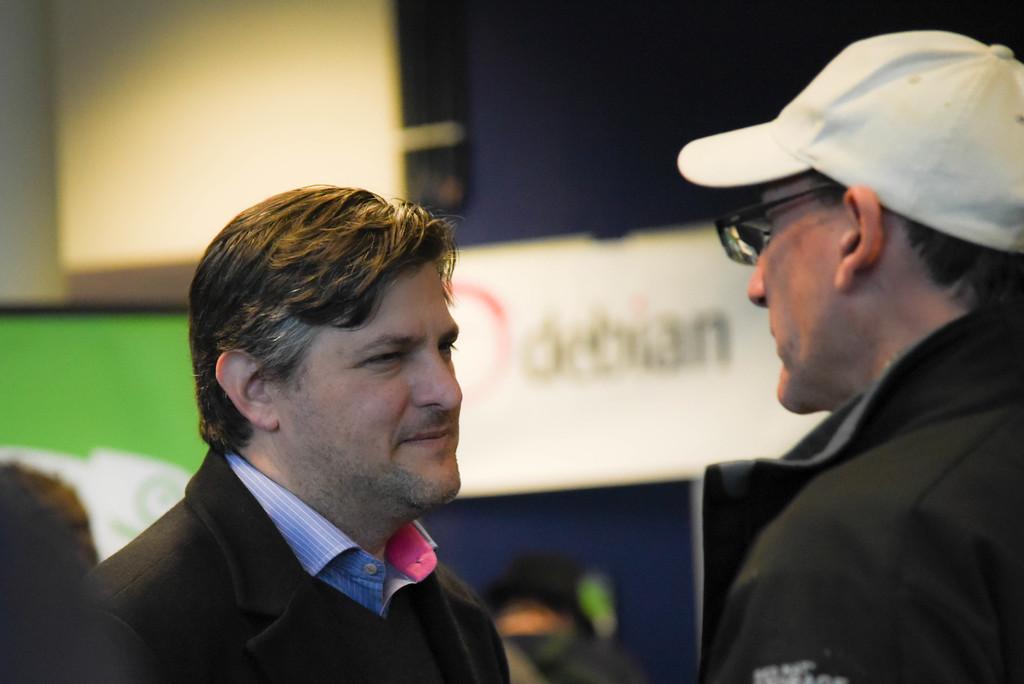In one or two sentences, can you explain what this image depicts? In this image I can see two people with black and blue color dresses. I can see one person with the specs and cap. In the background I can see the boards but it is blurry. 